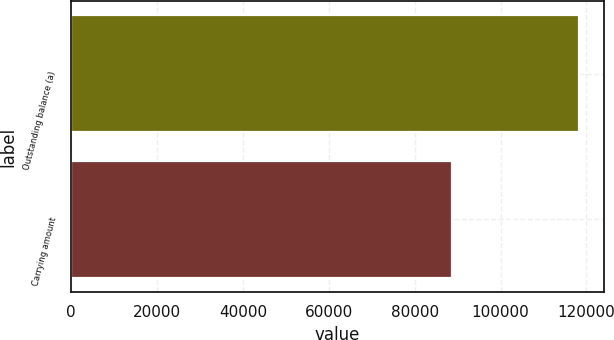<chart> <loc_0><loc_0><loc_500><loc_500><bar_chart><fcel>Outstanding balance (a)<fcel>Carrying amount<nl><fcel>118180<fcel>88813<nl></chart> 